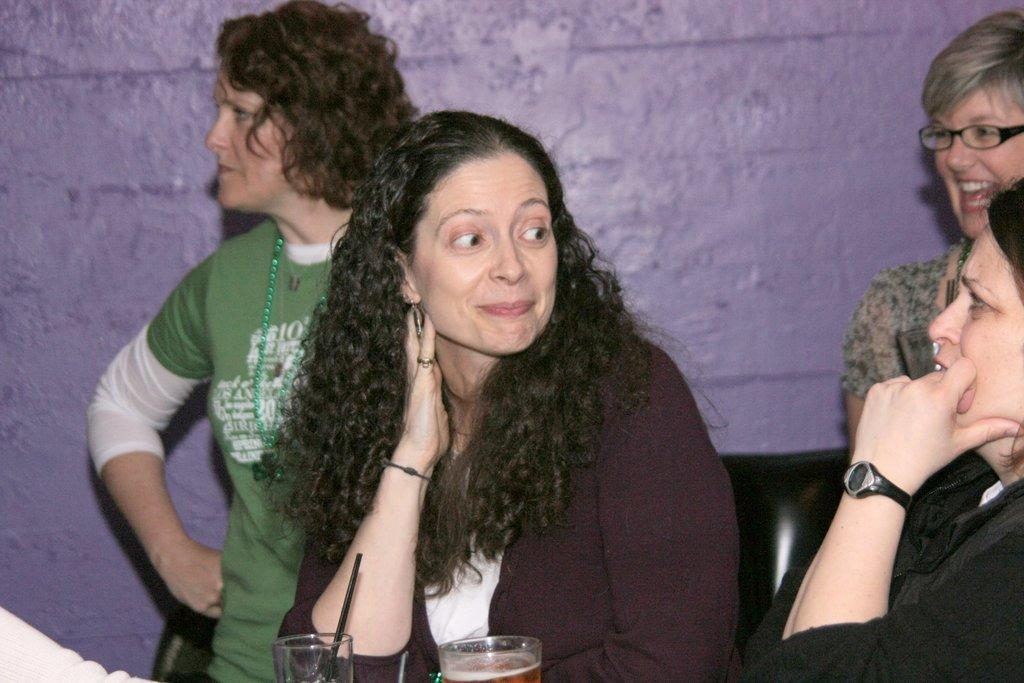Who or what is located in the center of the image? There are ladies in the center of the image. What objects can be seen at the bottom side of the image? There are glasses at the bottom side of the image. What is the purpose of the basketball in the image? There is no basketball present in the image. Can you provide more detail about the ladies' clothing in the image? The provided facts do not mention any details about the ladies' clothing, so we cannot provide more detail. 